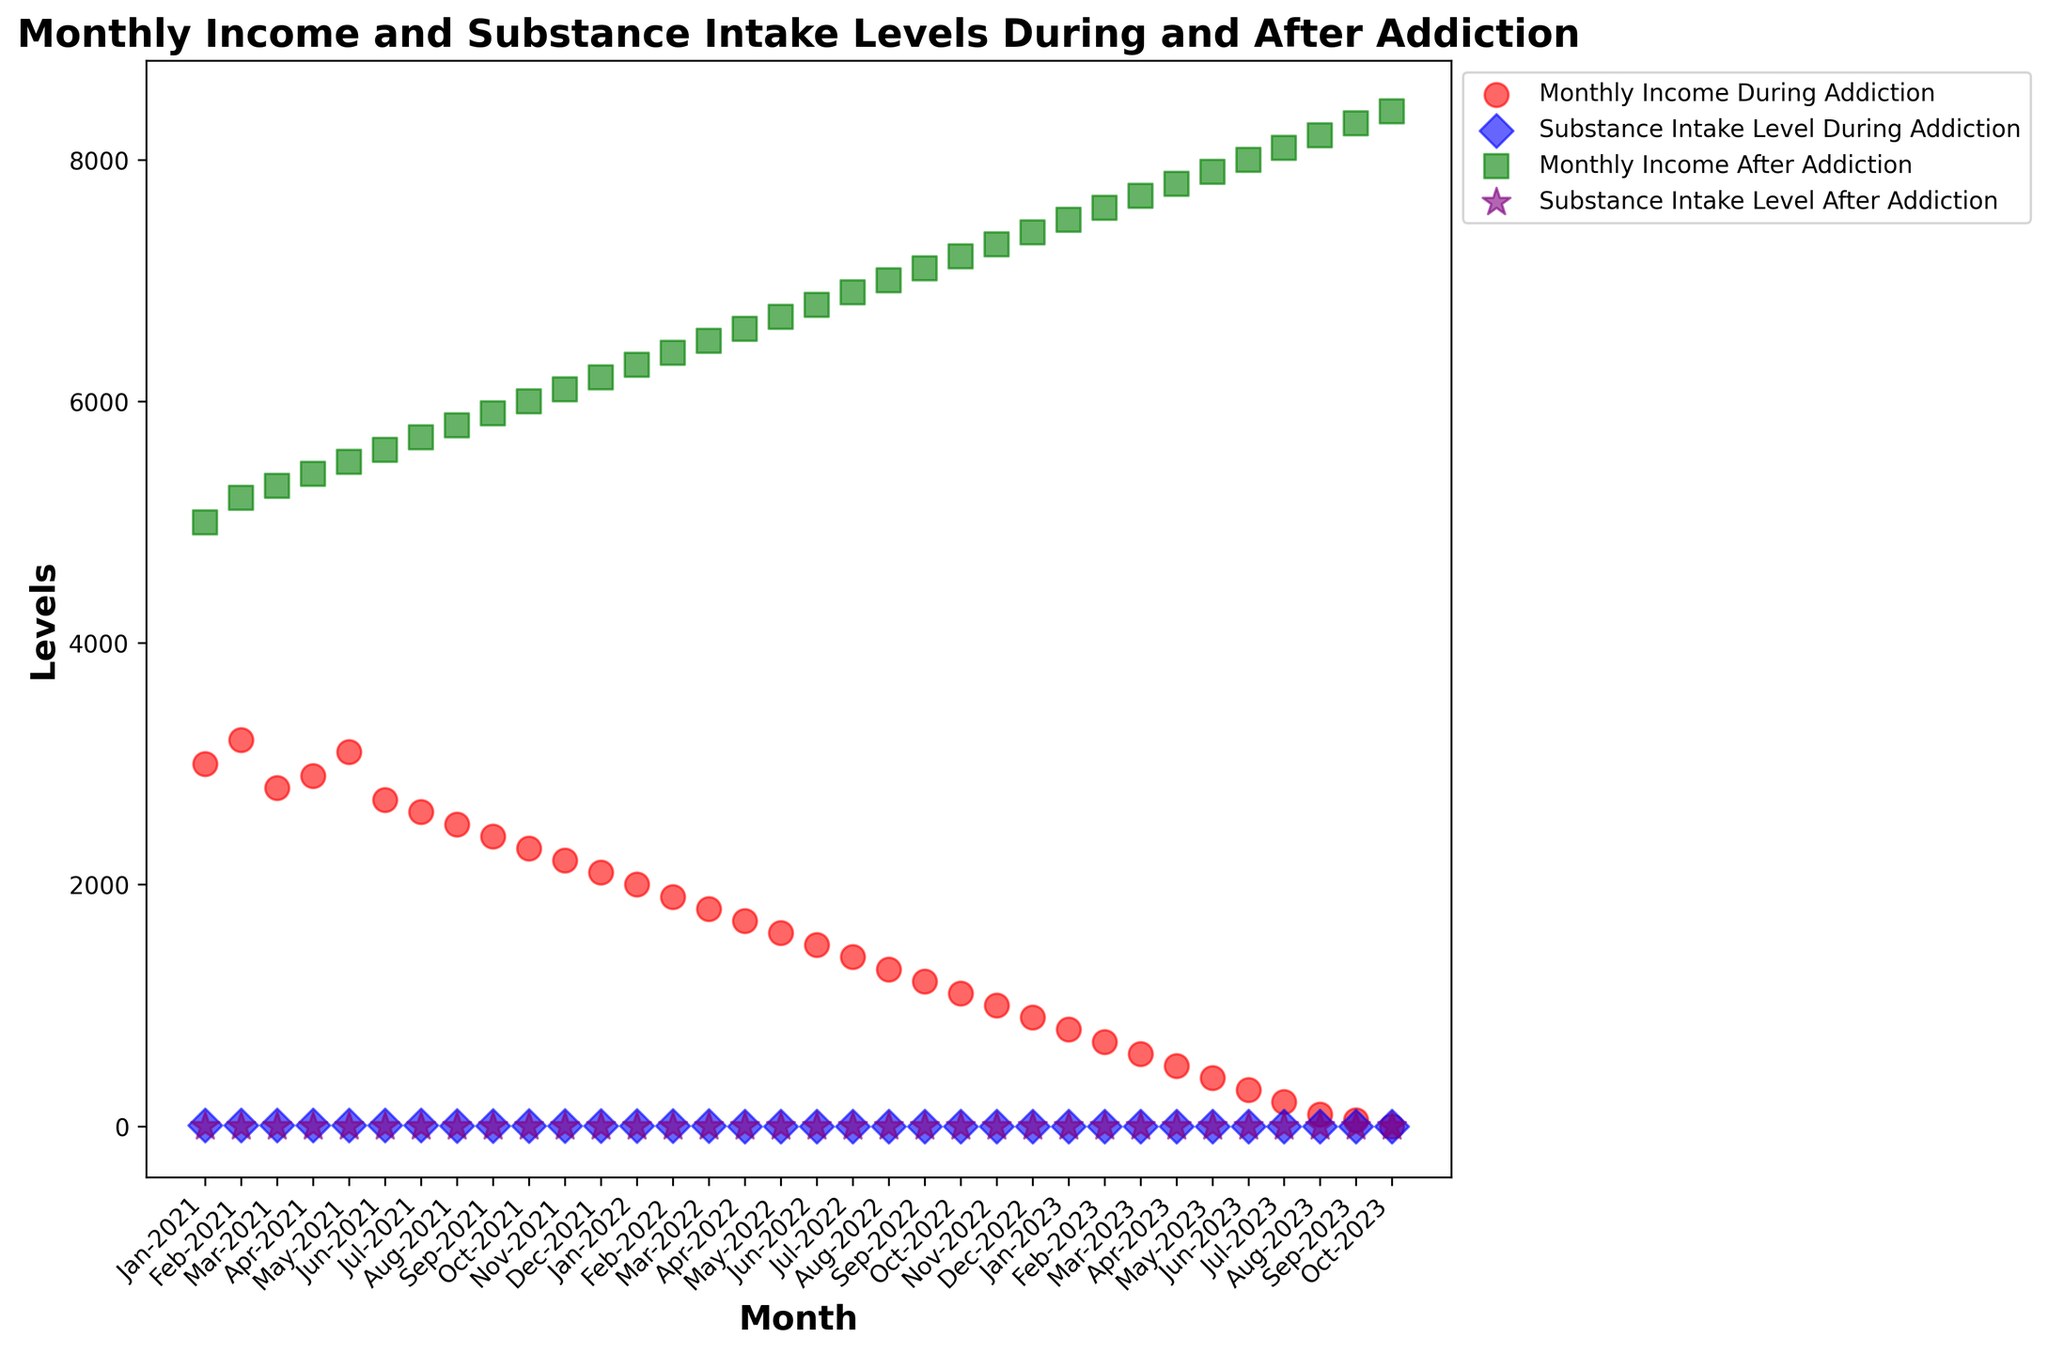What is the substance intake level during addiction in January 2023? According to the scatter plot, the substance intake level during addiction in January 2023 is represented by a blue diamond. This value is 3.
Answer: 3 How did the monthly income change between the beginning and the end of the addiction period? To answer this, observe the red scatter points from Jan-2021 to Oct-2023. The monthly income during addiction starts at $3000 in Jan-2021 and decreases to $0 by Oct-2023.
Answer: Decreased to $0 By how much did the monthly income increase from the end of addiction to May-2023? The monthly income at the end of addiction (Oct-2023) is $0. By May-2023, it has increased to $7900. The difference is $7900 - $0 = $7900.
Answer: $7900 Compare the substance intake levels during and after addiction for July 2022. The substance intake level during addiction in July 2022 is shown by a blue diamond (level 0), while the level after addiction is represented by a purple star (also level 0). Thus, both levels are the same.
Answer: Same What was the highest monthly income during addiction? The highest red scatter point indicates the highest monthly income during addiction, which is $3200 in Feb-2021.
Answer: $3200 How does the monthly income trend differ before and after addiction? Before addiction, represented by the red scatter points, the monthly income shows a general decreasing trend. After addiction, represented by the green scatter points, it shows a steady increase over time.
Answer: Decreased before, increased after Identify the first month when substance intake level dropped to 0 after addiction. Observing the purple star marks in the plot, the first month when the substance intake level drops to zero is in Jun-2022.
Answer: Jun-2022 What is the difference between the substance intake levels during and after addiction in May-2021? For May-2021, the substance intake level during addiction, shown by the blue diamond, is 7. There is no intake level after addiction represented for the same period.
Answer: Only during What is the overall trend of substance intake levels after addiction? Based on the purple star points in the scatter plot, the substance intake level is consistently at 0 after addiction starts.
Answer: Consistent at 0 What can you infer about the correlation between monthly income and substance intake levels during addiction? Visually comparing red and blue points, as substance intake levels (blue) decrease, monthly income (red) also declines during addiction, suggesting a positive correlation.
Answer: Positive correlation 